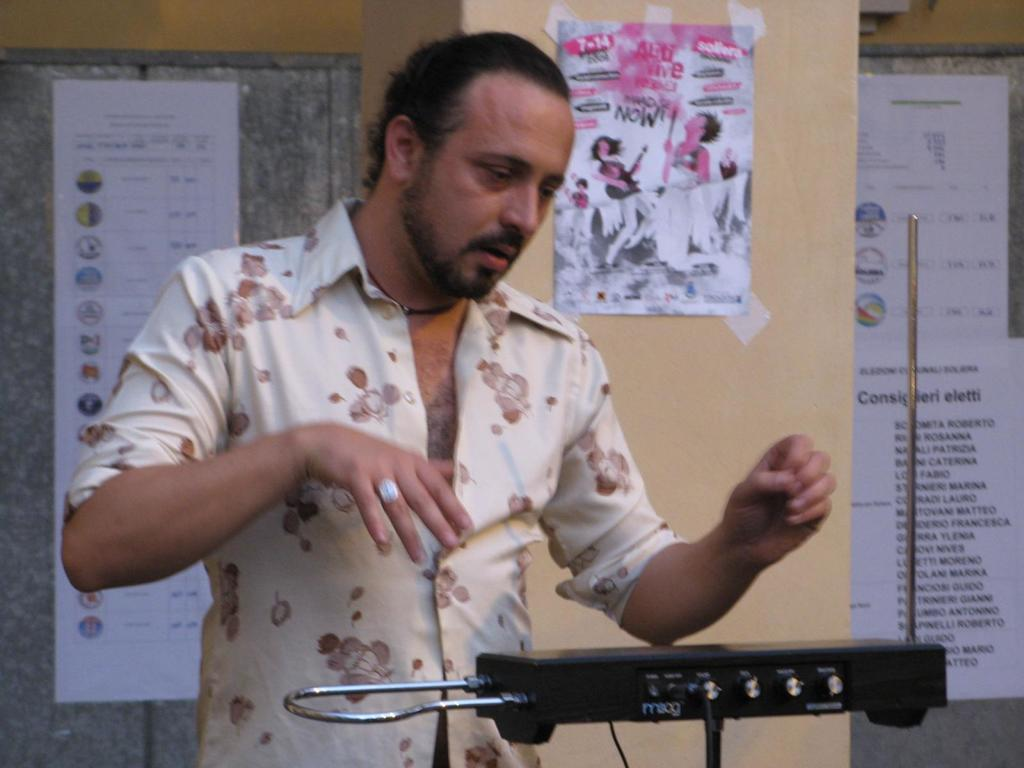What is the main subject of the image? There is a person standing in the image. What is the person doing in the image? The person is standing in front of an object. What can be seen in the background of the image? There are posters on the wall in the background of the image. How far away is the yoke from the person in the image? There is no yoke present in the image, so it cannot be determined how far away it might be from the person. 